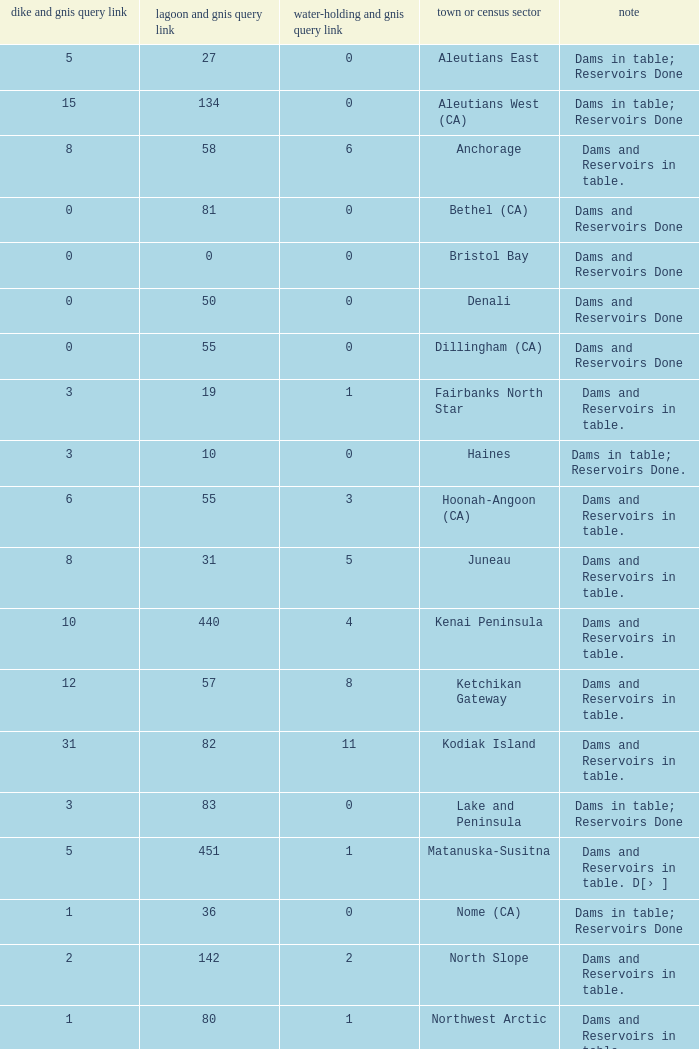Name the most numbers dam and gnis query link for borough or census area for fairbanks north star 3.0. 